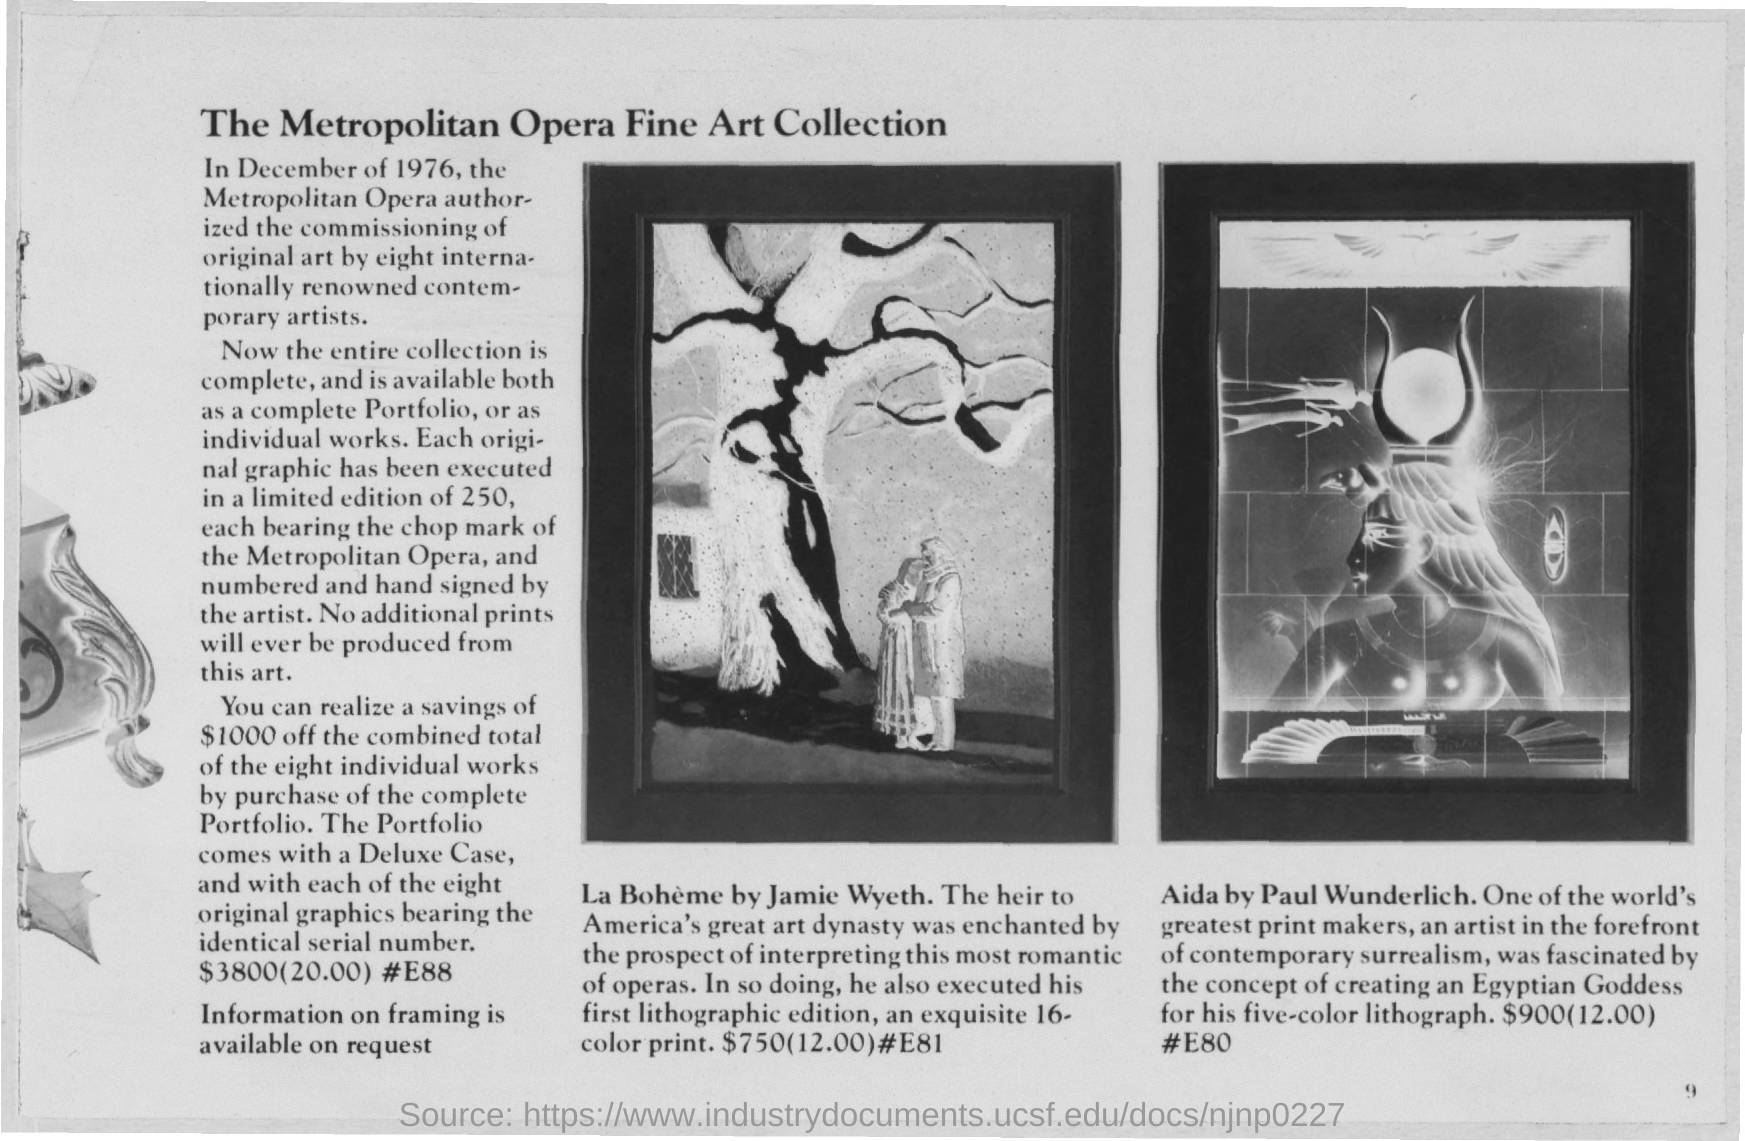What is the price of "La Boheme by Jamie Wyeth"?
Ensure brevity in your answer.  $750. What is the price of Aida by Paul Wunderlich?
Keep it short and to the point. $900. 